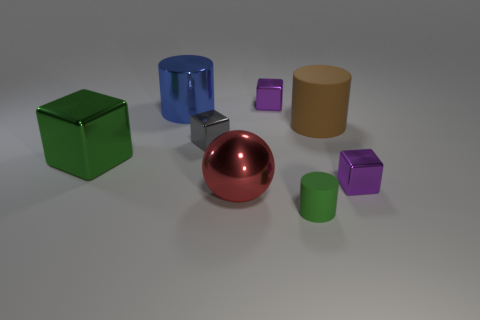The matte object that is the same color as the big block is what shape?
Ensure brevity in your answer.  Cylinder. What is the size of the cylinder that is the same color as the big shiny cube?
Make the answer very short. Small. What is the big object on the right side of the small purple shiny cube behind the large matte cylinder made of?
Provide a short and direct response. Rubber. What size is the purple object behind the small object that is right of the large cylinder right of the red sphere?
Give a very brief answer. Small. What number of large spheres are the same material as the gray thing?
Offer a very short reply. 1. What color is the shiny thing on the right side of the purple object behind the blue metal cylinder?
Your answer should be compact. Purple. What number of things are green matte cylinders or small gray cubes on the right side of the large metal cylinder?
Your response must be concise. 2. Is there a big rubber cylinder of the same color as the tiny cylinder?
Offer a very short reply. No. What number of cyan things are either big cubes or matte things?
Your response must be concise. 0. How many other things are there of the same size as the ball?
Your answer should be very brief. 3. 